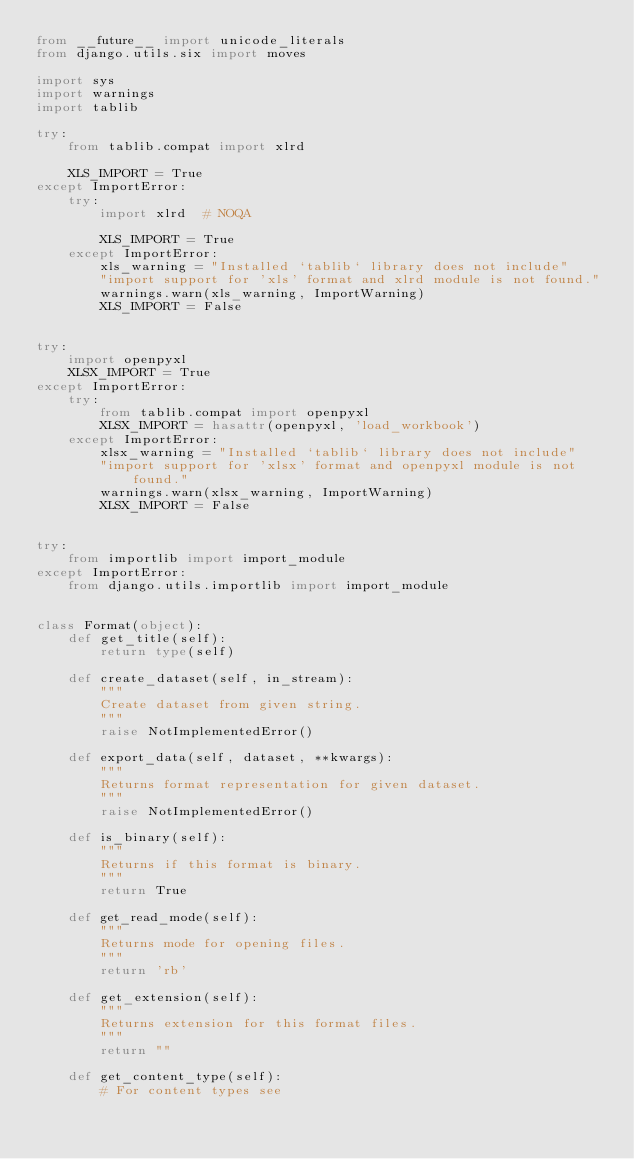Convert code to text. <code><loc_0><loc_0><loc_500><loc_500><_Python_>from __future__ import unicode_literals
from django.utils.six import moves

import sys
import warnings
import tablib

try:
    from tablib.compat import xlrd

    XLS_IMPORT = True
except ImportError:
    try:
        import xlrd  # NOQA

        XLS_IMPORT = True
    except ImportError:
        xls_warning = "Installed `tablib` library does not include"
        "import support for 'xls' format and xlrd module is not found."
        warnings.warn(xls_warning, ImportWarning)
        XLS_IMPORT = False


try:
    import openpyxl
    XLSX_IMPORT = True
except ImportError:
    try:
        from tablib.compat import openpyxl
        XLSX_IMPORT = hasattr(openpyxl, 'load_workbook')
    except ImportError:
        xlsx_warning = "Installed `tablib` library does not include"
        "import support for 'xlsx' format and openpyxl module is not found."
        warnings.warn(xlsx_warning, ImportWarning)
        XLSX_IMPORT = False


try:
    from importlib import import_module
except ImportError:
    from django.utils.importlib import import_module


class Format(object):
    def get_title(self):
        return type(self)

    def create_dataset(self, in_stream):
        """
        Create dataset from given string.
        """
        raise NotImplementedError()

    def export_data(self, dataset, **kwargs):
        """
        Returns format representation for given dataset.
        """
        raise NotImplementedError()

    def is_binary(self):
        """
        Returns if this format is binary.
        """
        return True

    def get_read_mode(self):
        """
        Returns mode for opening files.
        """
        return 'rb'

    def get_extension(self):
        """
        Returns extension for this format files.
        """
        return ""

    def get_content_type(self):
        # For content types see</code> 